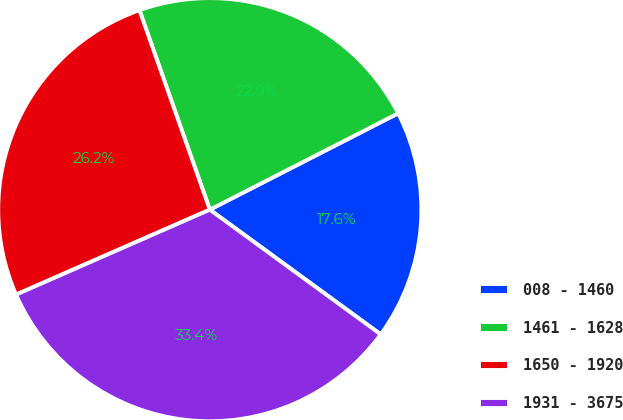Convert chart to OTSL. <chart><loc_0><loc_0><loc_500><loc_500><pie_chart><fcel>008 - 1460<fcel>1461 - 1628<fcel>1650 - 1920<fcel>1931 - 3675<nl><fcel>17.56%<fcel>22.87%<fcel>26.18%<fcel>33.39%<nl></chart> 